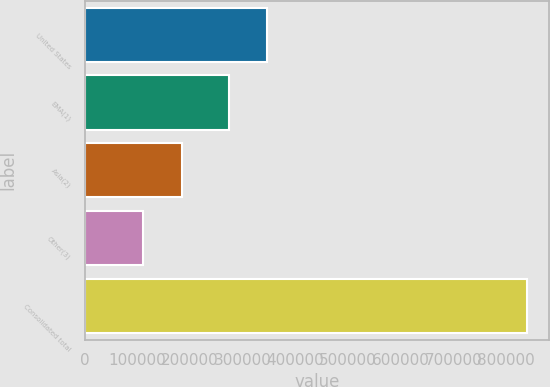Convert chart to OTSL. <chart><loc_0><loc_0><loc_500><loc_500><bar_chart><fcel>United States<fcel>EMA(1)<fcel>Asia(2)<fcel>Other(3)<fcel>Consolidated total<nl><fcel>346159<fcel>273274<fcel>184142<fcel>111257<fcel>840109<nl></chart> 